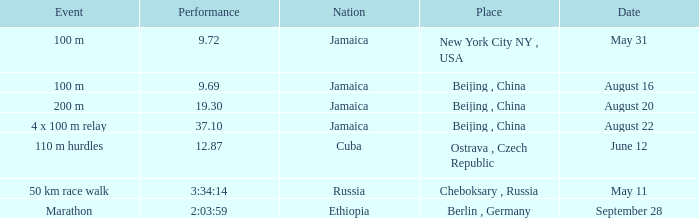Which nation ran a time of 9.69 seconds? Jamaica. 